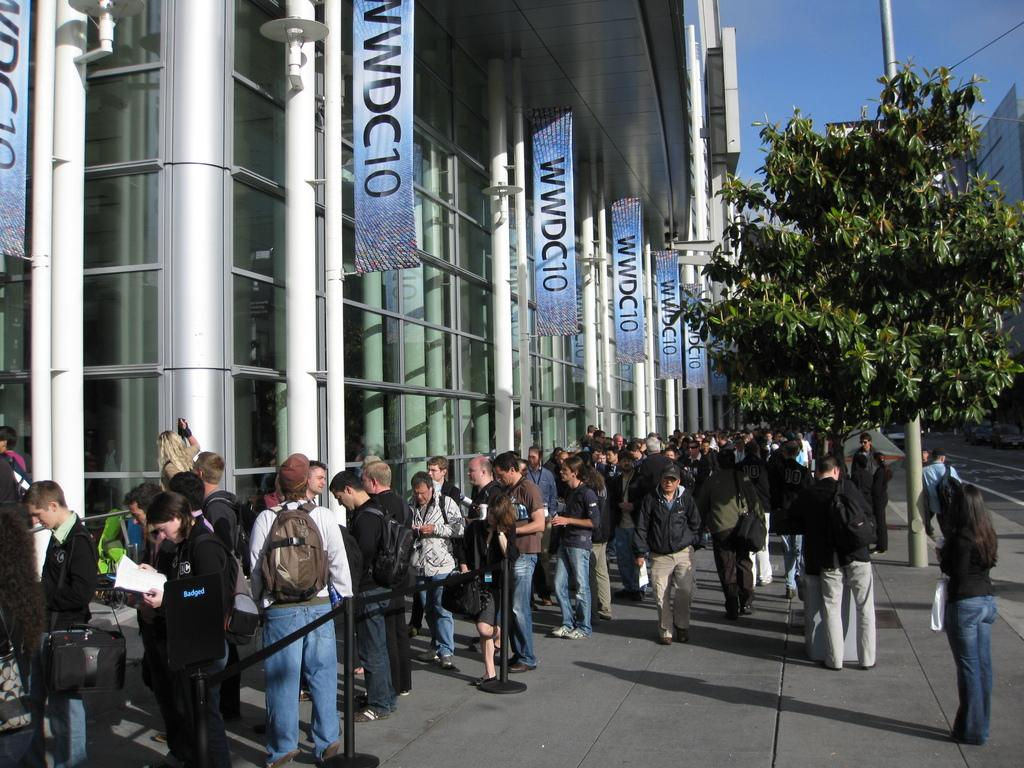Provide a one-sentence caption for the provided image. A crowd of people standing outside of the WWDC10 convention. 